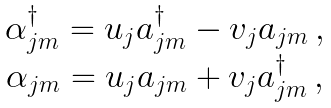Convert formula to latex. <formula><loc_0><loc_0><loc_500><loc_500>\begin{array} { c } \alpha ^ { \dagger } _ { j m } = u _ { j } a ^ { \dagger } _ { j m } - v _ { j } a _ { j m } \, , \\ \alpha _ { j m } = u _ { j } a _ { j m } + v _ { j } a ^ { \dagger } _ { j m } \, , \\ \end{array}</formula> 